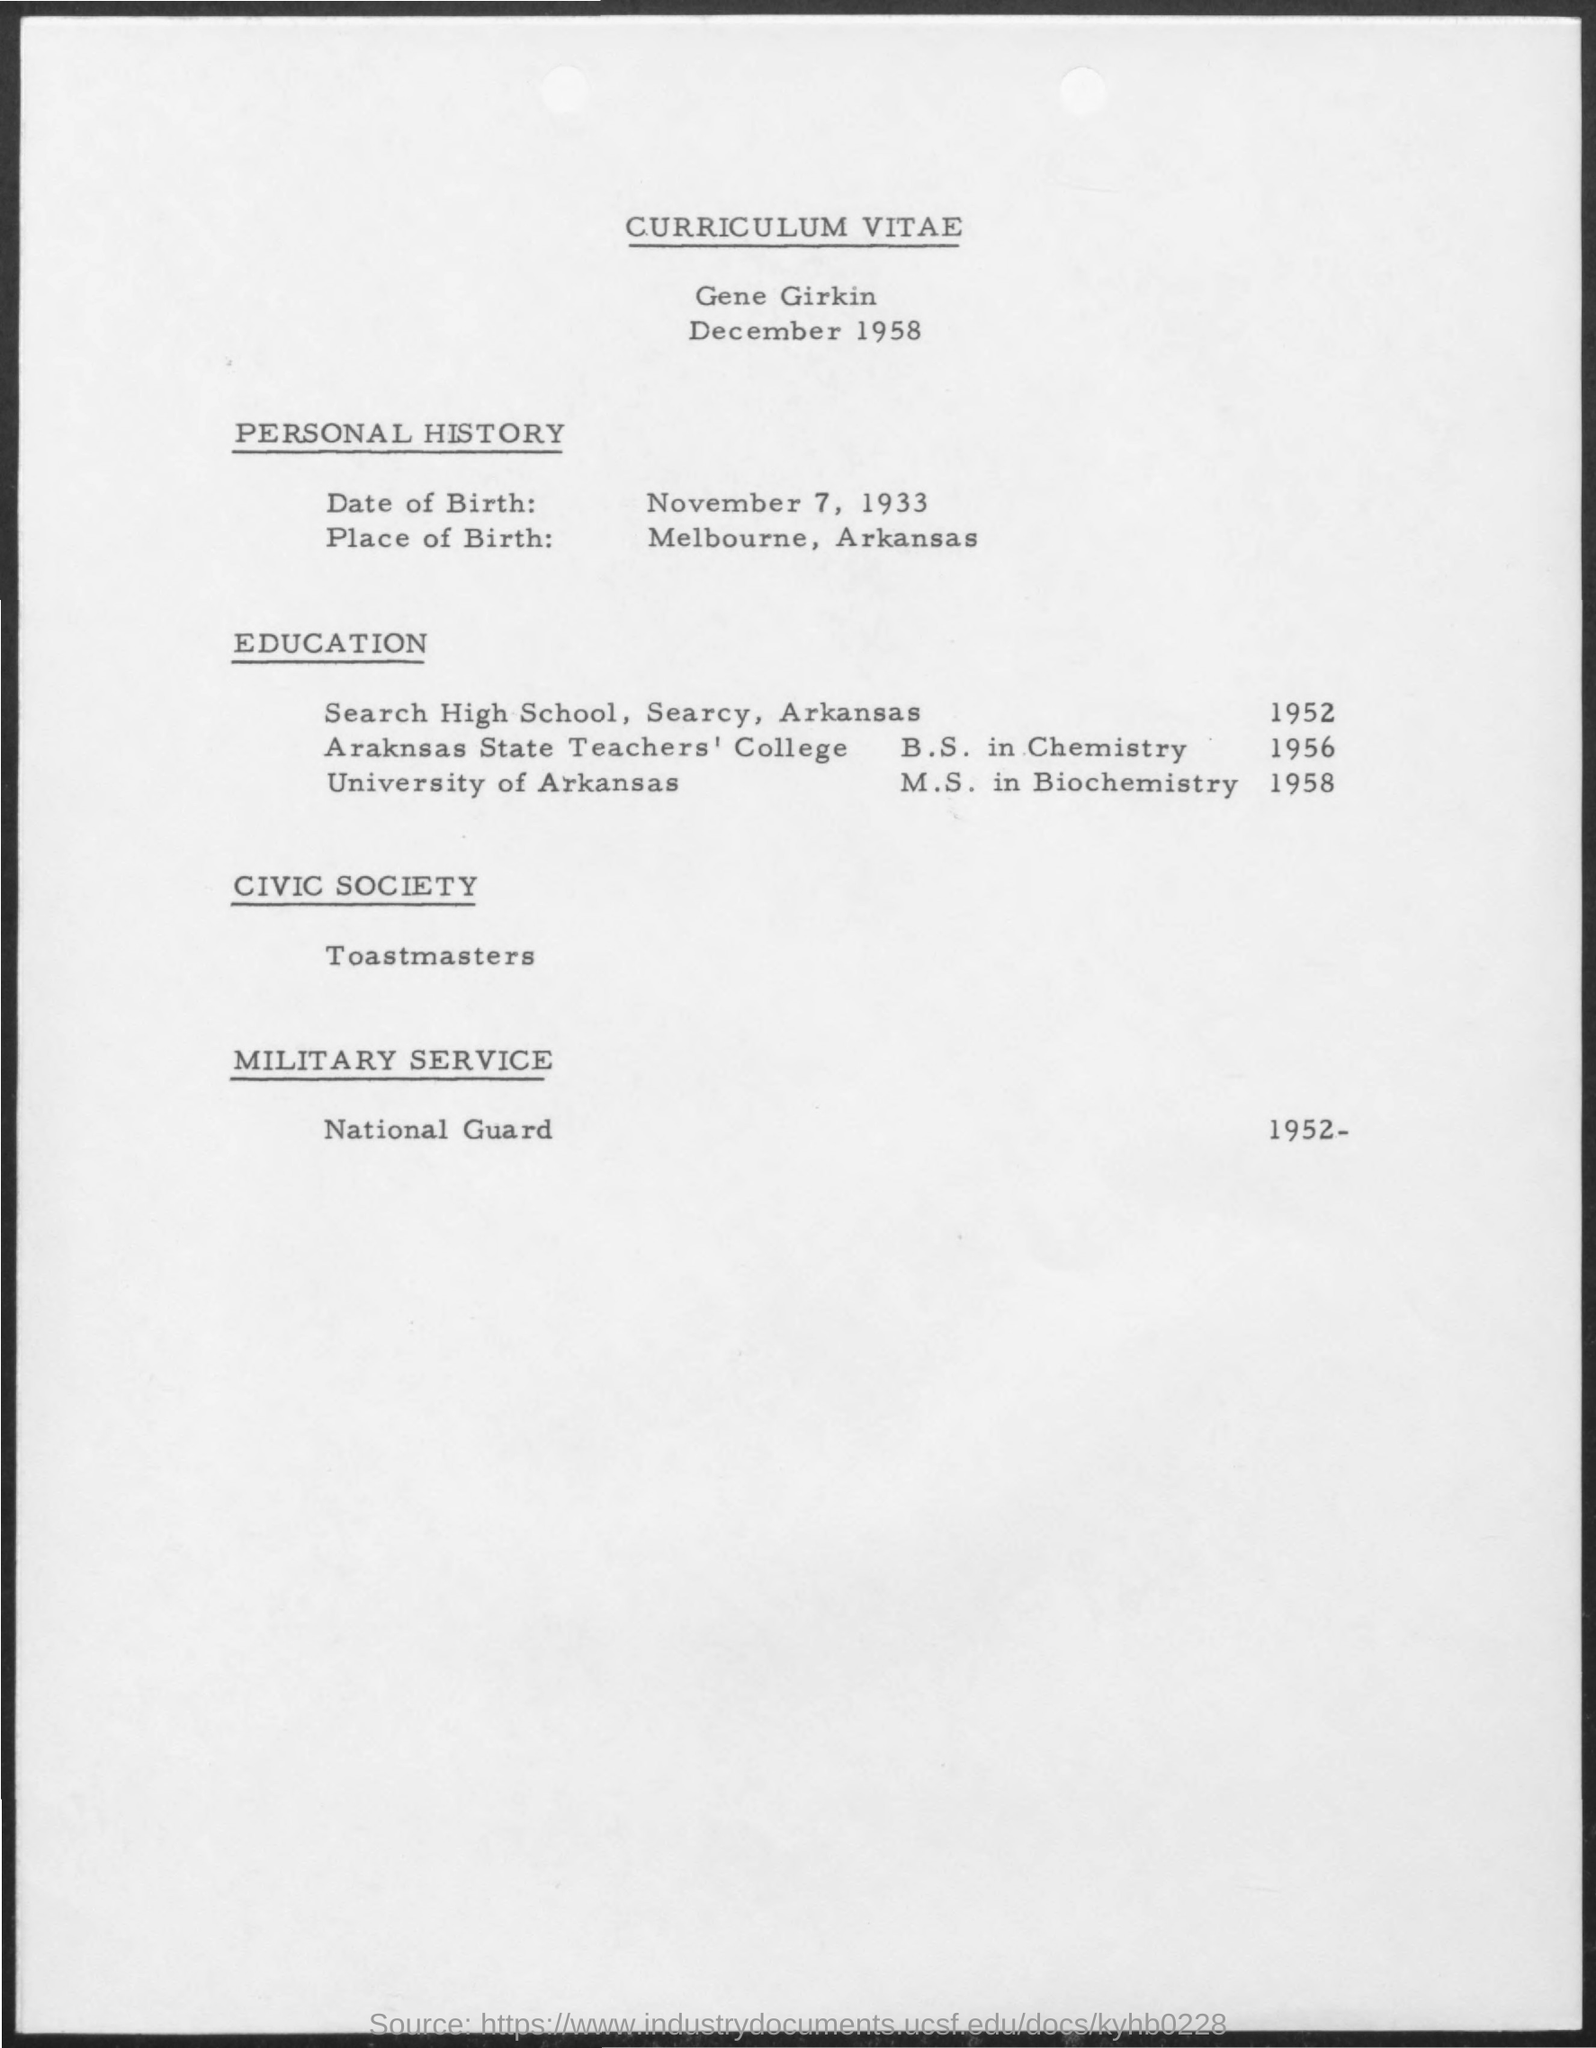Outline some significant characteristics in this image. The National Guard is the name of a military service that has been mentioned. The place of birth mentioned is Melbourne, Arkansas. The date of birth mentioned is November 7, 1933. The date mentioned is December 1958. The name of the civic society mentioned is Toastmasters. 